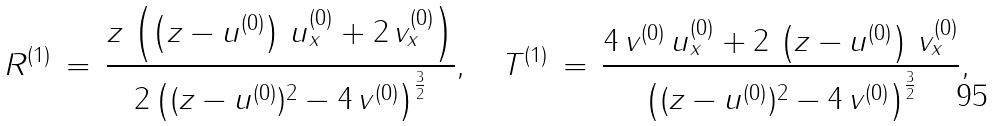Convert formula to latex. <formula><loc_0><loc_0><loc_500><loc_500>R ^ { ( 1 ) } \, = \, \frac { z \, \left ( \left ( z - u ^ { ( 0 ) } \right ) \, u ^ { ( 0 ) } _ { x } + 2 \, v ^ { ( 0 ) } _ { x } \right ) } { 2 \, { \left ( ( z - u ^ { ( 0 ) } ) ^ { 2 } - 4 \, v ^ { ( 0 ) } \right ) } ^ { \frac { 3 } { 2 } } } , \quad T ^ { ( 1 ) } \, = \, \frac { 4 \, v ^ { ( 0 ) } \, u ^ { ( 0 ) } _ { x } + 2 \, \left ( z - u ^ { ( 0 ) } \right ) \, v ^ { ( 0 ) } _ { x } } { { \left ( ( z - u ^ { ( 0 ) } ) ^ { 2 } - 4 \, v ^ { ( 0 ) } \right ) } ^ { \frac { 3 } { 2 } } } ,</formula> 